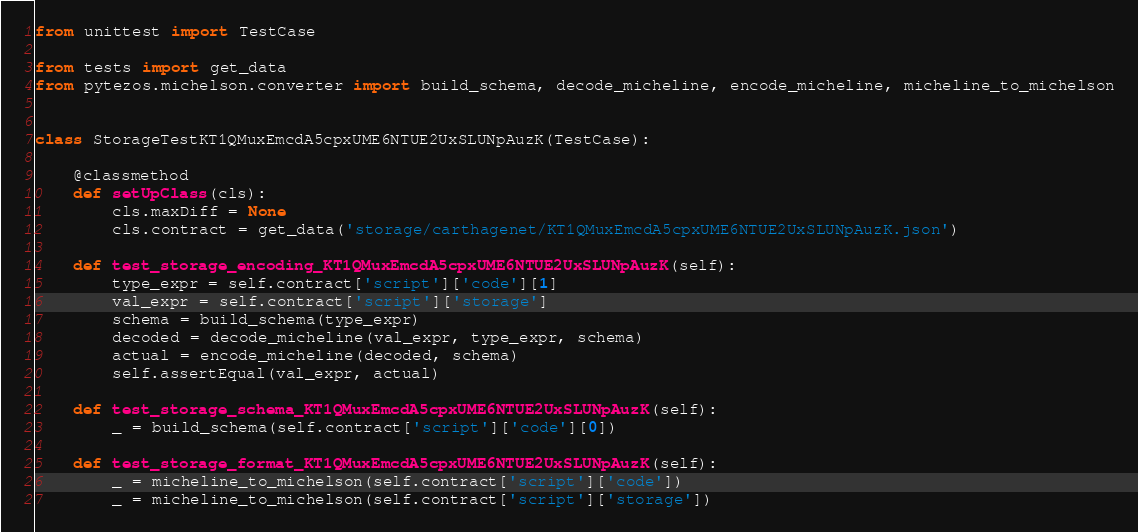Convert code to text. <code><loc_0><loc_0><loc_500><loc_500><_Python_>from unittest import TestCase

from tests import get_data
from pytezos.michelson.converter import build_schema, decode_micheline, encode_micheline, micheline_to_michelson


class StorageTestKT1QMuxEmcdA5cpxUME6NTUE2UxSLUNpAuzK(TestCase):

    @classmethod
    def setUpClass(cls):
        cls.maxDiff = None
        cls.contract = get_data('storage/carthagenet/KT1QMuxEmcdA5cpxUME6NTUE2UxSLUNpAuzK.json')

    def test_storage_encoding_KT1QMuxEmcdA5cpxUME6NTUE2UxSLUNpAuzK(self):
        type_expr = self.contract['script']['code'][1]
        val_expr = self.contract['script']['storage']
        schema = build_schema(type_expr)
        decoded = decode_micheline(val_expr, type_expr, schema)
        actual = encode_micheline(decoded, schema)
        self.assertEqual(val_expr, actual)

    def test_storage_schema_KT1QMuxEmcdA5cpxUME6NTUE2UxSLUNpAuzK(self):
        _ = build_schema(self.contract['script']['code'][0])

    def test_storage_format_KT1QMuxEmcdA5cpxUME6NTUE2UxSLUNpAuzK(self):
        _ = micheline_to_michelson(self.contract['script']['code'])
        _ = micheline_to_michelson(self.contract['script']['storage'])
</code> 